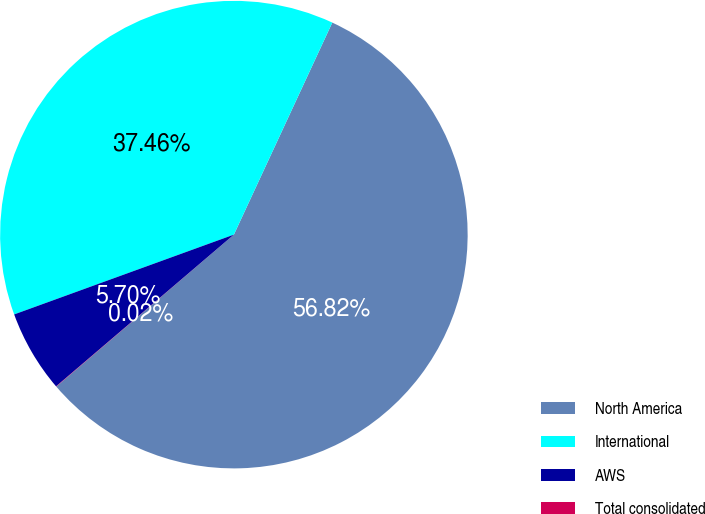Convert chart to OTSL. <chart><loc_0><loc_0><loc_500><loc_500><pie_chart><fcel>North America<fcel>International<fcel>AWS<fcel>Total consolidated<nl><fcel>56.82%<fcel>37.46%<fcel>5.7%<fcel>0.02%<nl></chart> 